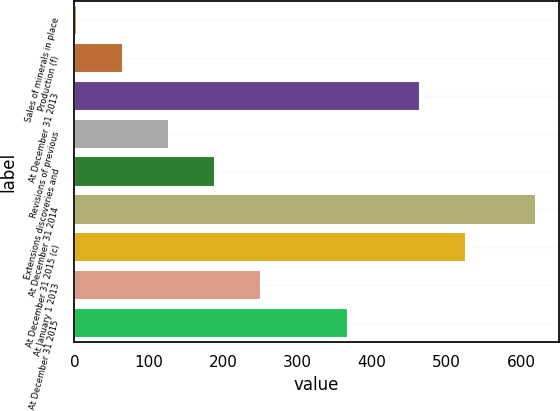Convert chart to OTSL. <chart><loc_0><loc_0><loc_500><loc_500><bar_chart><fcel>Sales of minerals in place<fcel>Production (f)<fcel>At December 31 2013<fcel>Revisions of previous<fcel>Extensions discoveries and<fcel>At December 31 2014<fcel>At December 31 2015 (c)<fcel>At January 1 2013<fcel>At December 31 2015<nl><fcel>4<fcel>65.6<fcel>464<fcel>127.2<fcel>188.8<fcel>620<fcel>525.6<fcel>250.4<fcel>368<nl></chart> 